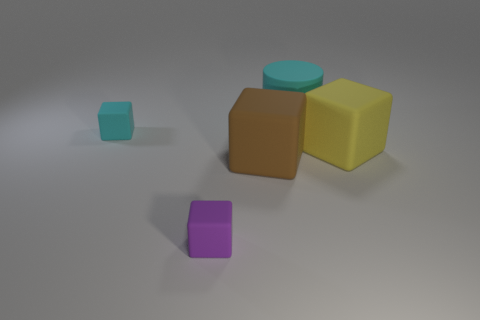Subtract 1 blocks. How many blocks are left? 3 Add 2 large purple shiny cylinders. How many objects exist? 7 Subtract all cylinders. How many objects are left? 4 Add 3 brown matte cubes. How many brown matte cubes exist? 4 Subtract 0 green blocks. How many objects are left? 5 Subtract all small cyan blocks. Subtract all blue metallic cylinders. How many objects are left? 4 Add 5 big matte blocks. How many big matte blocks are left? 7 